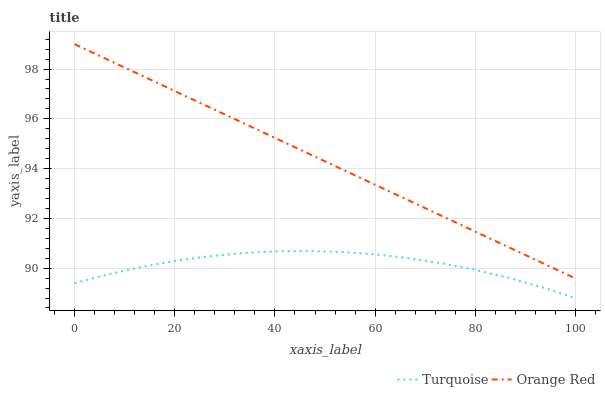Does Turquoise have the minimum area under the curve?
Answer yes or no. Yes. Does Orange Red have the maximum area under the curve?
Answer yes or no. Yes. Does Orange Red have the minimum area under the curve?
Answer yes or no. No. Is Orange Red the smoothest?
Answer yes or no. Yes. Is Turquoise the roughest?
Answer yes or no. Yes. Is Orange Red the roughest?
Answer yes or no. No. Does Turquoise have the lowest value?
Answer yes or no. Yes. Does Orange Red have the lowest value?
Answer yes or no. No. Does Orange Red have the highest value?
Answer yes or no. Yes. Is Turquoise less than Orange Red?
Answer yes or no. Yes. Is Orange Red greater than Turquoise?
Answer yes or no. Yes. Does Turquoise intersect Orange Red?
Answer yes or no. No. 